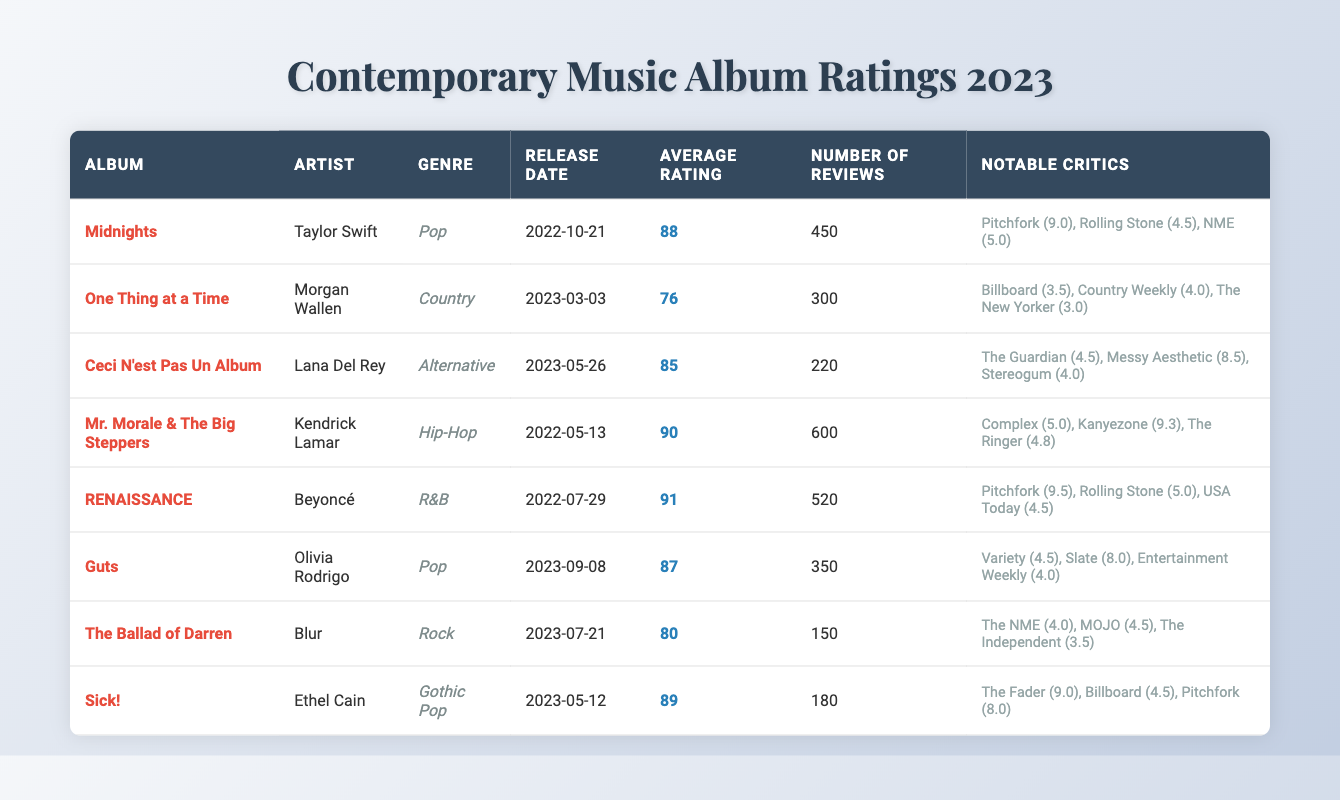What is the average rating of the album "Midnights"? The table lists the average rating for "Midnights" as 88.
Answer: 88 Which album has the highest average rating? By comparing the average ratings of all albums, "RENAISSANCE" has the highest average rating of 91.
Answer: RENAISSANCE How many reviews did "Guts" receive? The number of reviews for "Guts" is stated in the table as 350.
Answer: 350 Is "Ceci N'est Pas Un Album" rated higher than 80? The average rating for "Ceci N'est Pas Un Album" is 85, which is greater than 80. Therefore, the answer is yes.
Answer: Yes What is the difference in average ratings between "Mr. Morale & The Big Steppers" and "One Thing at a Time"? The average rating for "Mr. Morale & The Big Steppers" is 90, and for "One Thing at a Time" is 76. The difference is 90 - 76 = 14.
Answer: 14 How many albums are categorized as Pop? The table lists two albums under the Pop genre: "Midnights" and "Guts".
Answer: 2 Which artist has the highest-rated album based on notable critics' ratings? Comparing the notable critics' ratings, "RENAISSANCE" has the highest rating by Pitchfork (9.5). Therefore, Beyoncé has the highest-rated album.
Answer: Beyoncé What is the average rating of the albums in the Pop genre? "Midnights" has a rating of 88 and "Guts" has a rating of 87. The average rating is (88 + 87) / 2 = 87.5.
Answer: 87.5 Which album has the fewest number of reviews? "The Ballad of Darren" has the fewest reviews at 150 according to the table.
Answer: The Ballad of Darren Which genre has the average rating of 89 or higher? Only the genres of R&B ("RENAISSANCE", rating 91) and Gothic Pop ("Sick!", rating 89) have average ratings of 89 or higher.
Answer: R&B and Gothic Pop Calculate the average rating of albums by Kendrick Lamar and Taylor Swift. "Mr. Morale & The Big Steppers" by Kendrick Lamar has an average rating of 90 and "Midnights" by Taylor Swift has 88. The average rating is (90 + 88) / 2 = 89.
Answer: 89 How many notable critics rated "Sick!"? The album "Sick!" has three notable critics listed: The Fader, Billboard, and Pitchfork.
Answer: 3 Is the release date of "The Ballad of Darren" earlier than "Ceci N'est Pas Un Album"? "The Ballad of Darren" was released on 2023-07-21, and "Ceci N'est Pas Un Album" was released on 2023-05-26, so it is not.
Answer: No 